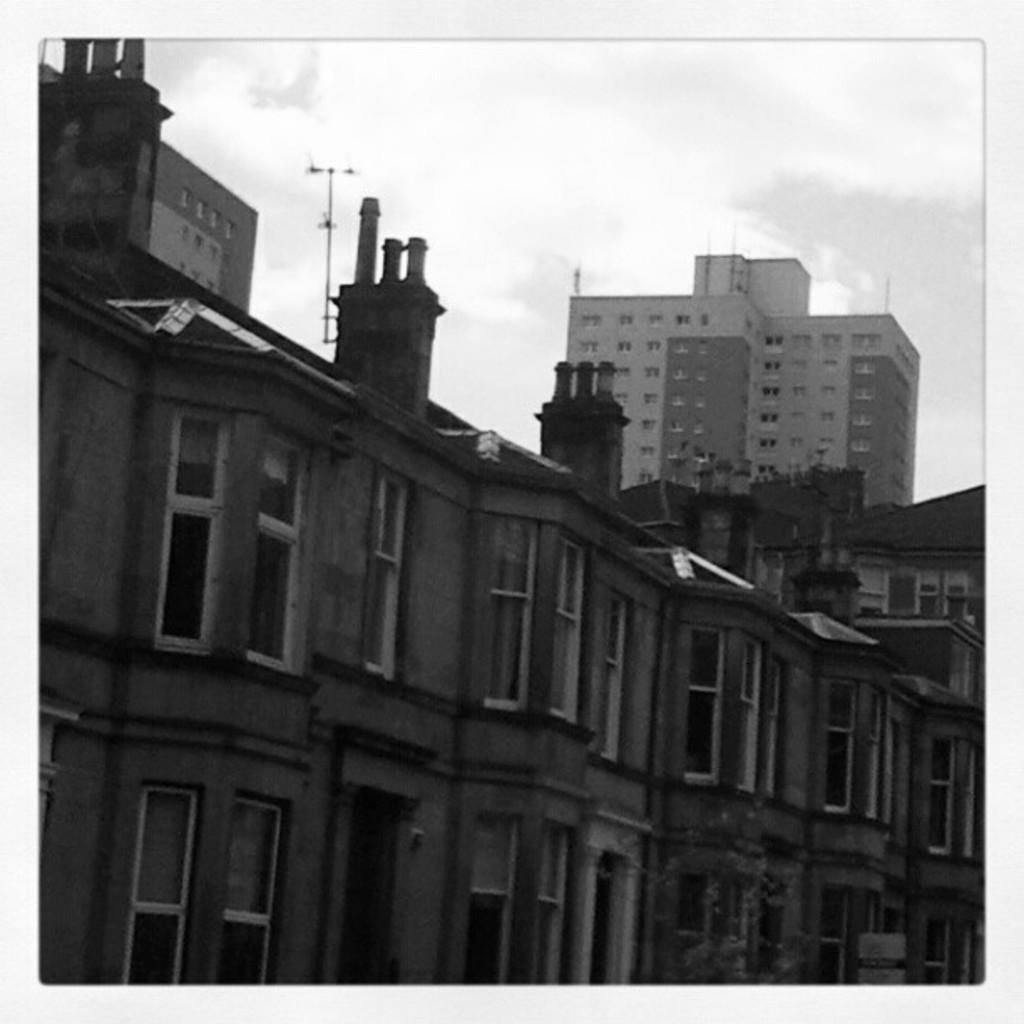What is the main subject in the center of the image? There are buildings in the center of the image. What type of windows do the buildings have? The buildings have glass windows. What is visible at the top of the image? The sky is visible at the top of the image. How many matches can be seen on the buildings in the image? There are no matches present in the image; it features buildings with glass windows and a visible sky. 